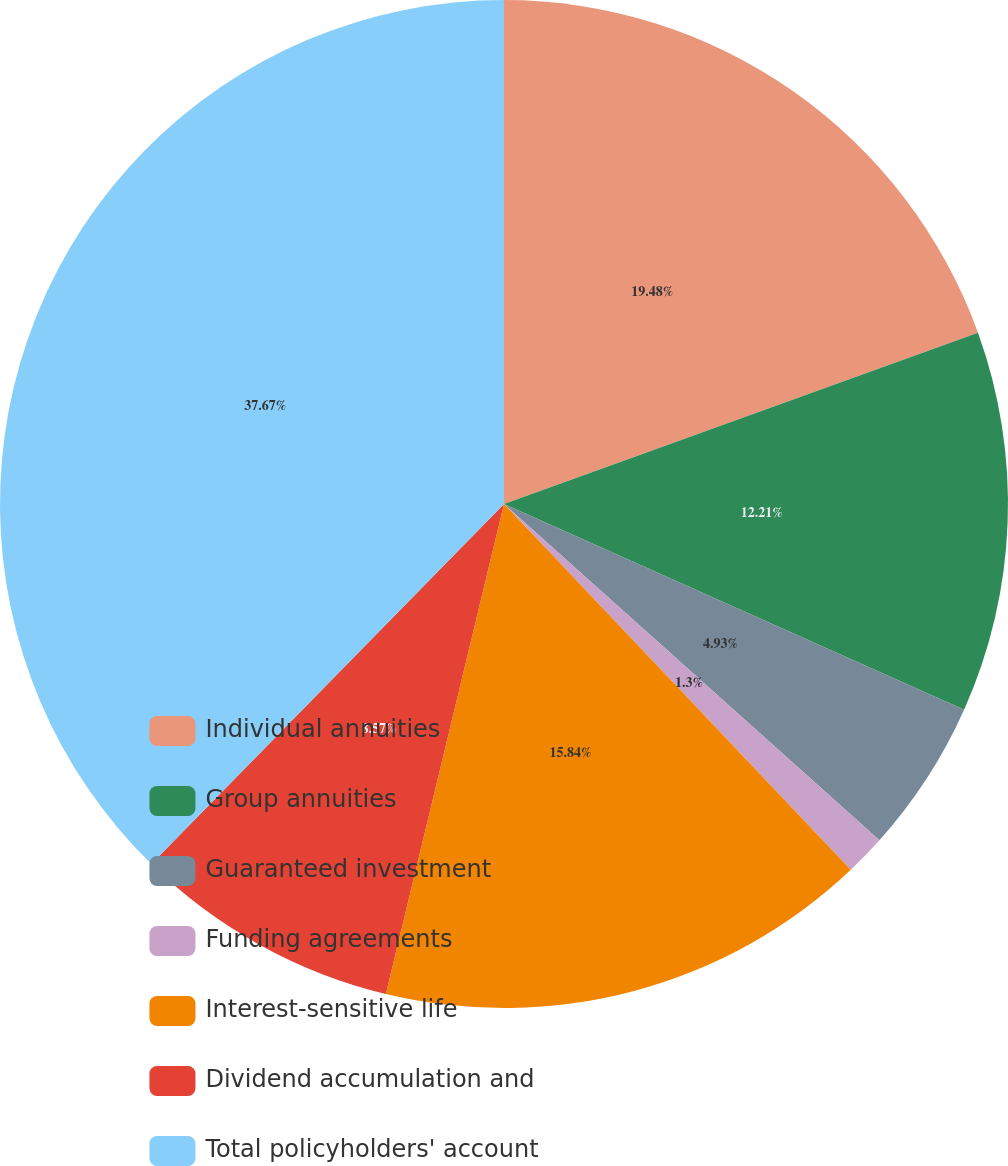<chart> <loc_0><loc_0><loc_500><loc_500><pie_chart><fcel>Individual annuities<fcel>Group annuities<fcel>Guaranteed investment<fcel>Funding agreements<fcel>Interest-sensitive life<fcel>Dividend accumulation and<fcel>Total policyholders' account<nl><fcel>19.48%<fcel>12.21%<fcel>4.93%<fcel>1.3%<fcel>15.84%<fcel>8.57%<fcel>37.66%<nl></chart> 